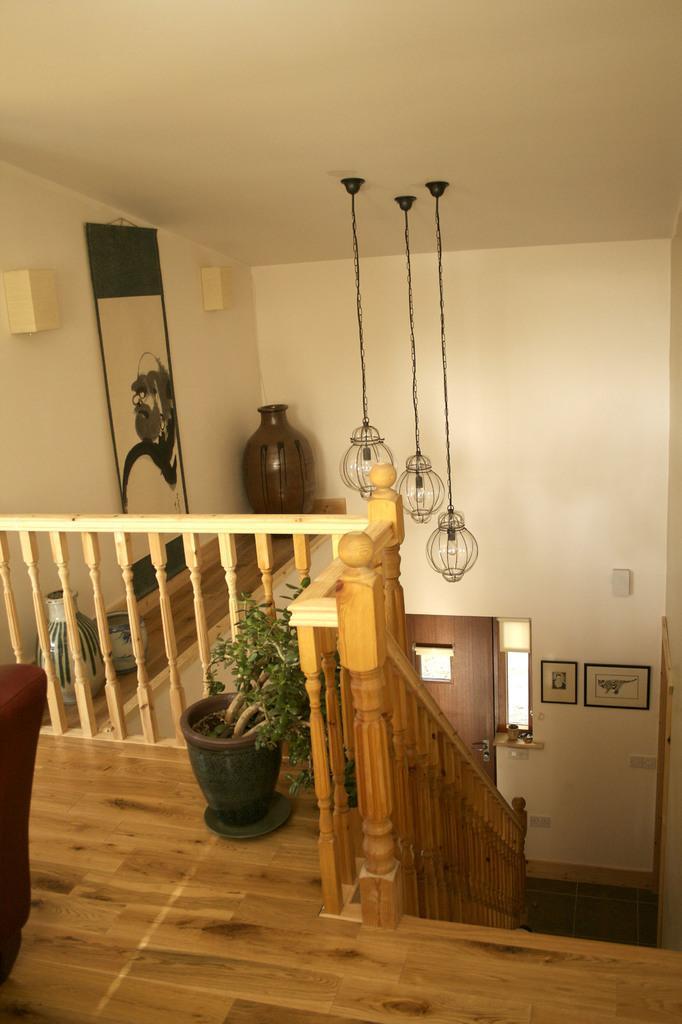Please provide a concise description of this image. This picture is clicked inside the room. In this picture, we see a staircase and beside that, there is a stair railing. Beside that, we see a flower pot. There is a wall in white color on which the photo frame is placed. Beside that, we see a pot. At the top of the picture, we see the lanterns and the roof of the building. On the left side, we see the sofa chair. 